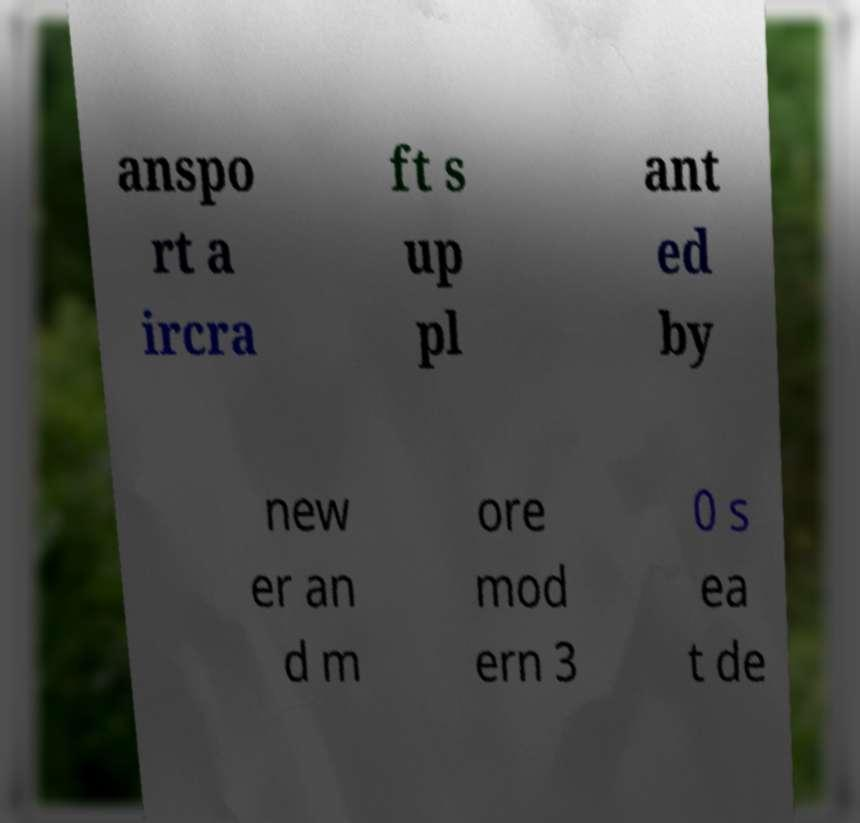Can you read and provide the text displayed in the image?This photo seems to have some interesting text. Can you extract and type it out for me? anspo rt a ircra ft s up pl ant ed by new er an d m ore mod ern 3 0 s ea t de 